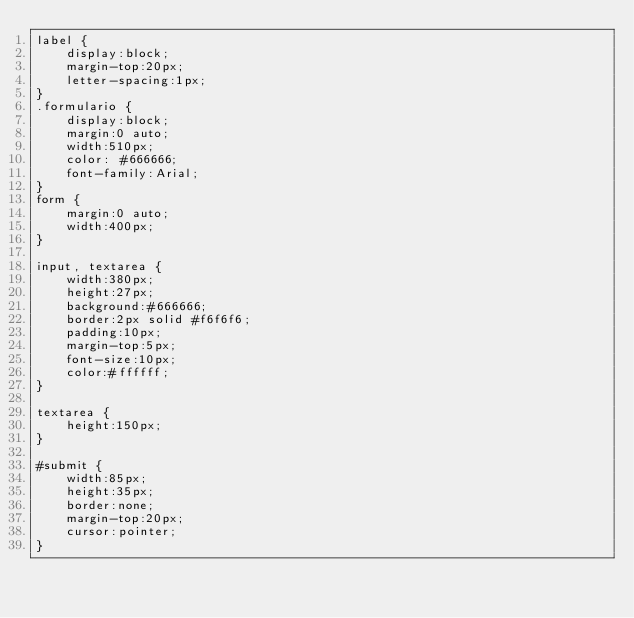Convert code to text. <code><loc_0><loc_0><loc_500><loc_500><_CSS_>label {
    display:block;
    margin-top:20px;
    letter-spacing:1px;
}
.formulario {
    display:block;
    margin:0 auto;
    width:510px;
    color: #666666;
    font-family:Arial;
}
form {
    margin:0 auto;
    width:400px;
}
 
input, textarea {
    width:380px;
    height:27px;
    background:#666666;
    border:2px solid #f6f6f6;
    padding:10px;
    margin-top:5px;
    font-size:10px;
    color:#ffffff;
}
 
textarea {
    height:150px;
}
 
#submit {
    width:85px;
    height:35px;
    border:none;
    margin-top:20px;
    cursor:pointer;
}
</code> 